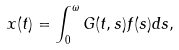Convert formula to latex. <formula><loc_0><loc_0><loc_500><loc_500>x ( t ) = \int _ { 0 } ^ { \omega } G ( t , s ) f ( s ) d s ,</formula> 